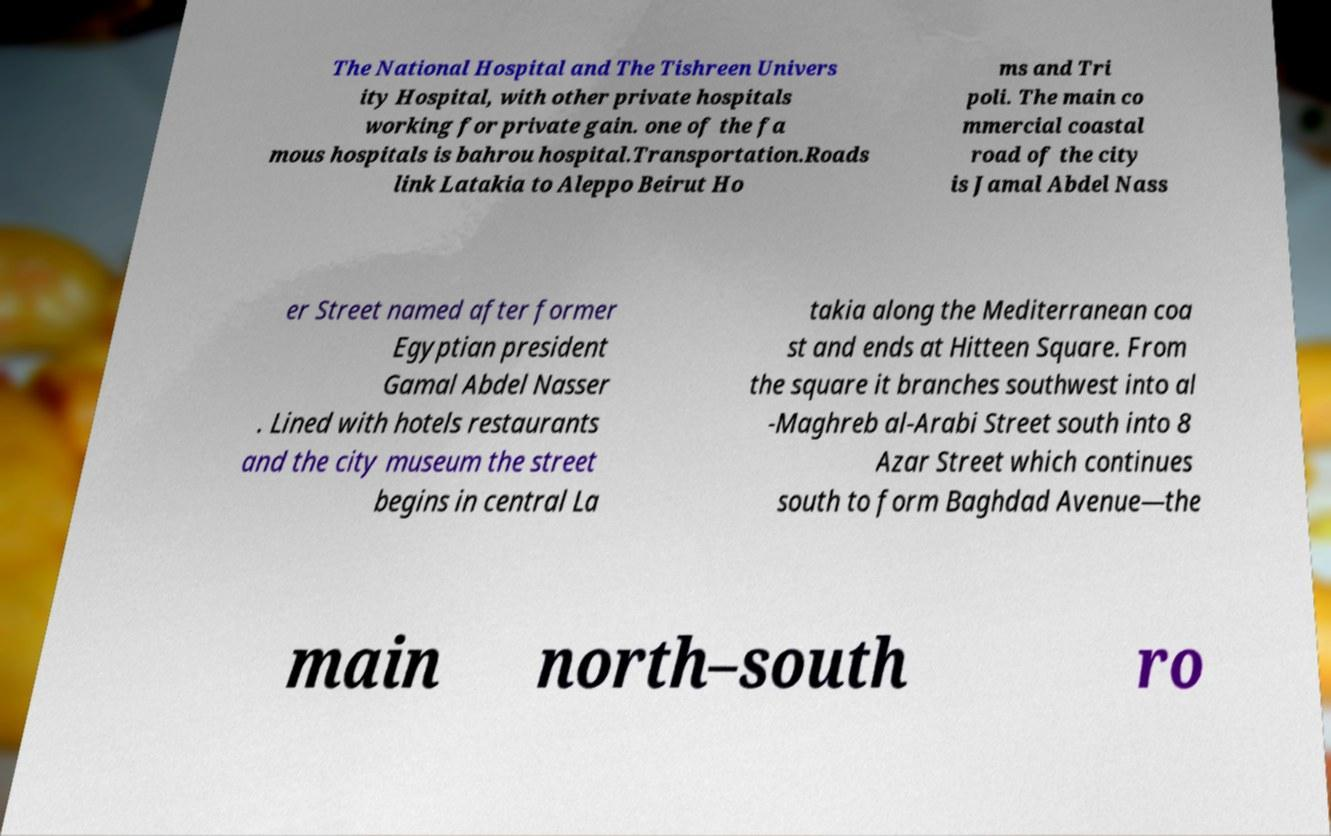Can you read and provide the text displayed in the image?This photo seems to have some interesting text. Can you extract and type it out for me? The National Hospital and The Tishreen Univers ity Hospital, with other private hospitals working for private gain. one of the fa mous hospitals is bahrou hospital.Transportation.Roads link Latakia to Aleppo Beirut Ho ms and Tri poli. The main co mmercial coastal road of the city is Jamal Abdel Nass er Street named after former Egyptian president Gamal Abdel Nasser . Lined with hotels restaurants and the city museum the street begins in central La takia along the Mediterranean coa st and ends at Hitteen Square. From the square it branches southwest into al -Maghreb al-Arabi Street south into 8 Azar Street which continues south to form Baghdad Avenue—the main north–south ro 